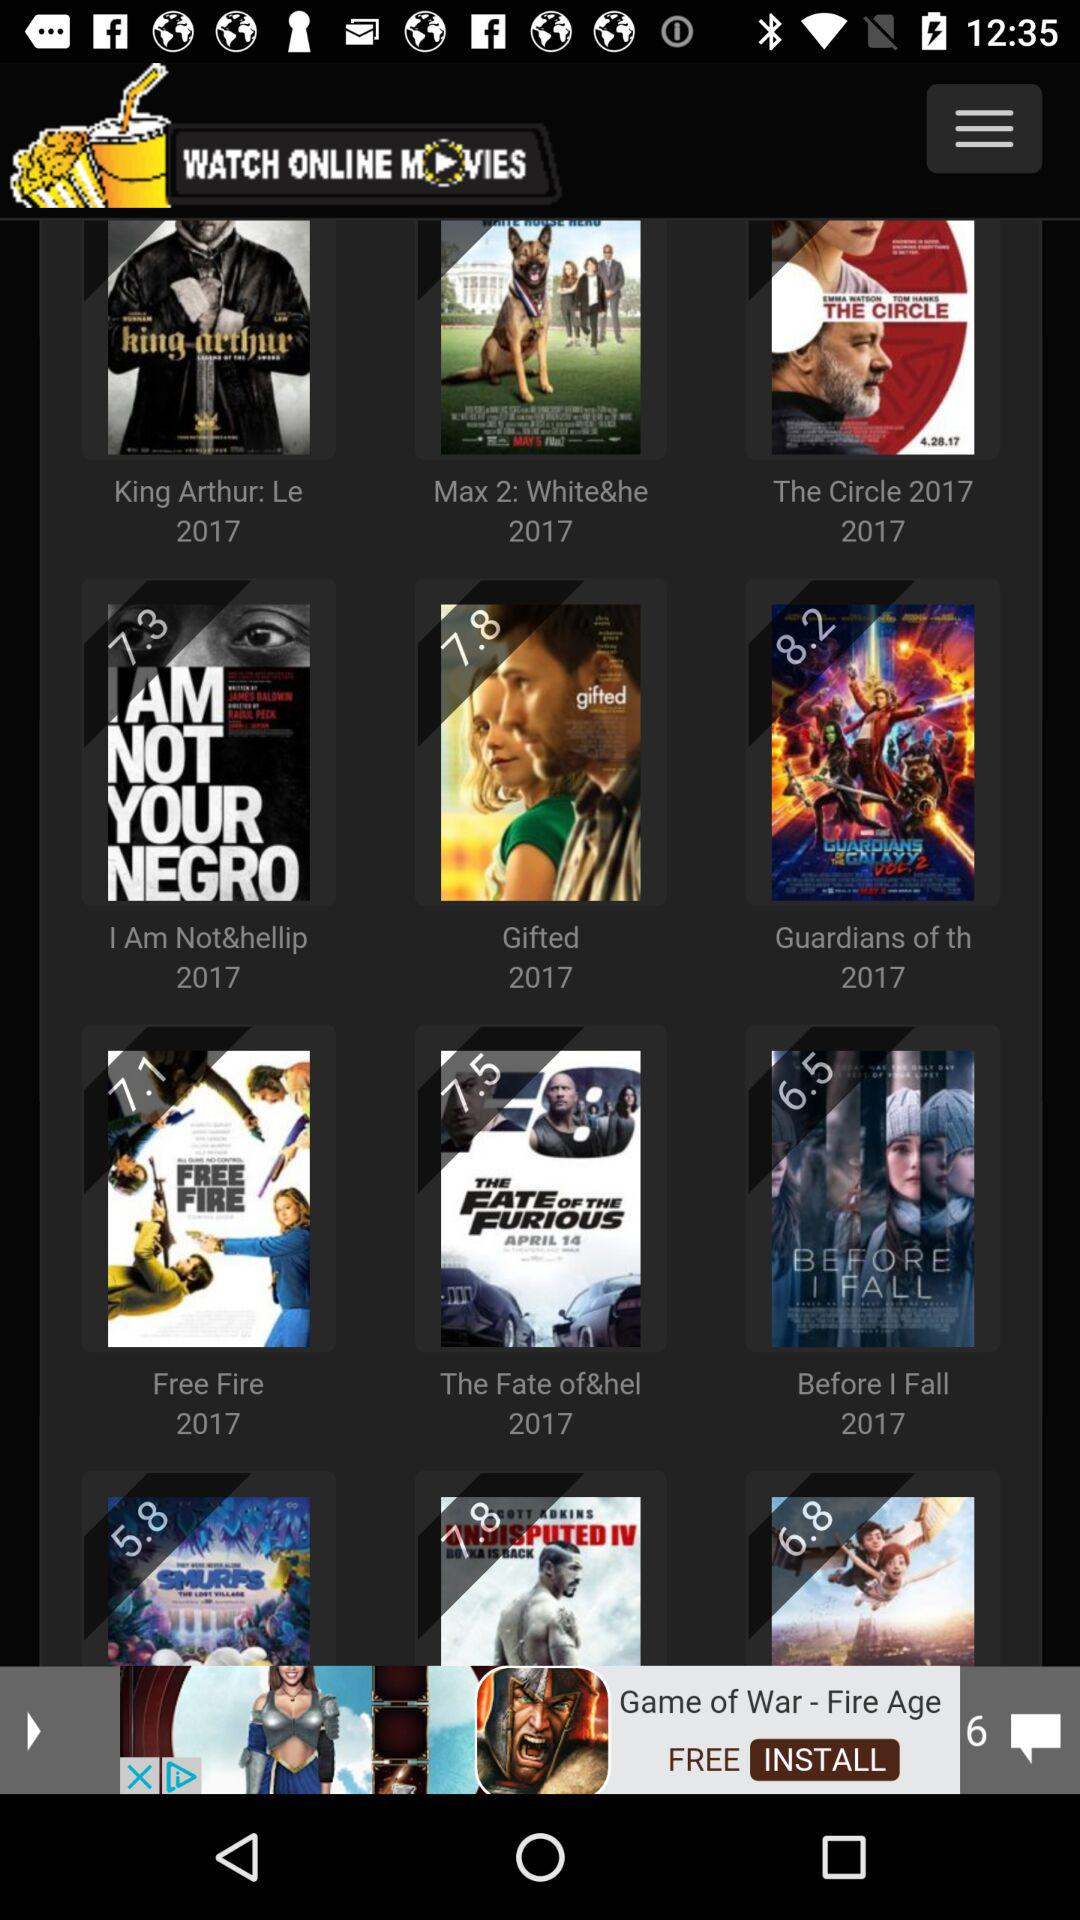What are the names of the displayed movies? The names of the movies are "King Arthur: Le", "Max 2: White&he", "The Circle 2017", "I Am Not&hellip", "Gifted", "Guardians of th", "Free Fire", "The Fate of&hel" and "Before I Fall". 